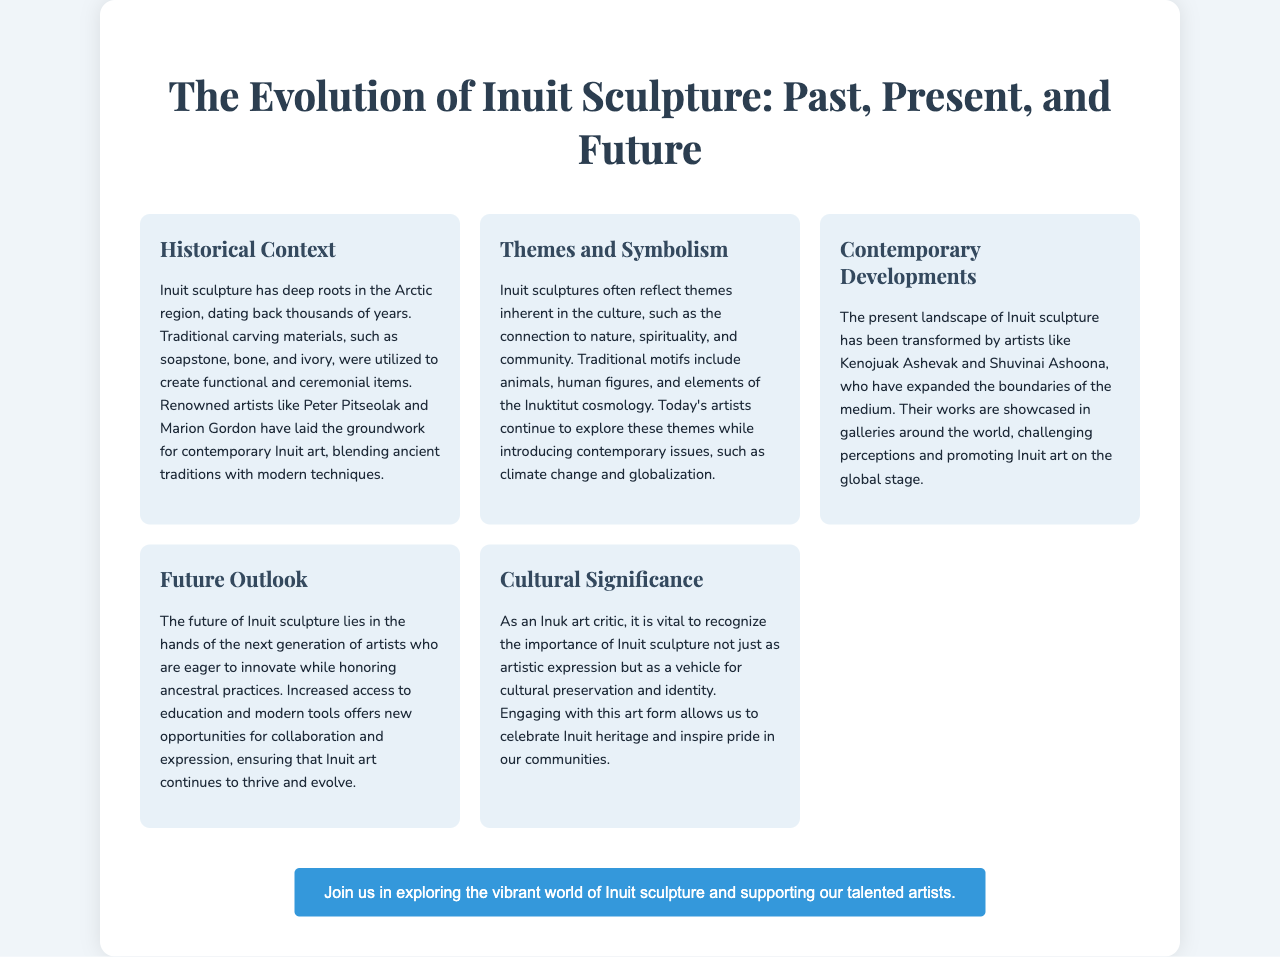What is the title of the brochure? The title of the brochure is prominently displayed in the header section, summarizing the main topic of the document.
Answer: The Evolution of Inuit Sculpture: Past, Present, and Future Who are two renowned artists mentioned in the historical context? The brochure highlights specific artists in the historical context section to illustrate the evolution of Inuit sculpture.
Answer: Peter Pitseolak and Marion Gordon What material is traditionally used for Inuit sculptures? The traditional materials utilized in creating Inuit sculptures are detailed in the historical context section.
Answer: Soapstone, bone, and ivory What contemporary issue do today's Inuit artists explore? The themes and symbolism section mentions contemporary issues that current Inuit artists address in their works.
Answer: Climate change Which artist is mentioned in the contemporary developments section? The section on contemporary developments identifies influential artists contributing to the modern Inuit art landscape.
Answer: Kenojuak Ashevak What is the main cultural significance of Inuit sculpture? The brochure succinctly captures why Inuit sculpture is important beyond artistic merit, emphasizing its role in cultural identity.
Answer: Cultural preservation and identity What is the future outlook for Inuit sculpture? The future outlook section provides insight into the anticipated developments and opportunities for Inuit sculpture going forward.
Answer: Innovation while honoring ancestral practices What can individuals do to engage with Inuit sculpture? The call-to-action section encourages people to partake in the appreciation and support of Inuit art and artists.
Answer: Join us in exploring the vibrant world of Inuit sculpture 